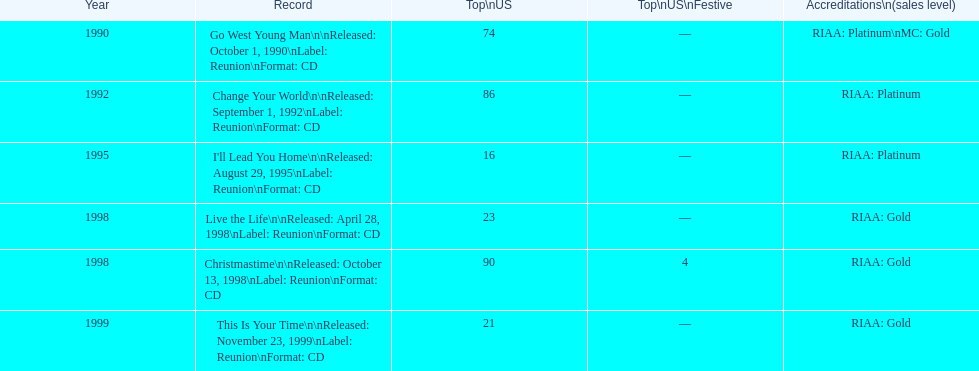What is the number of michael w smith albums that made it to the top 25 of the charts? 3. 